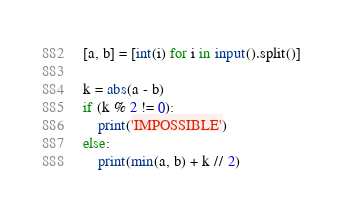Convert code to text. <code><loc_0><loc_0><loc_500><loc_500><_Python_>[a, b] = [int(i) for i in input().split()]

k = abs(a - b)
if (k % 2 != 0):
    print('IMPOSSIBLE')
else:
    print(min(a, b) + k // 2)
</code> 